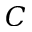<formula> <loc_0><loc_0><loc_500><loc_500>C</formula> 